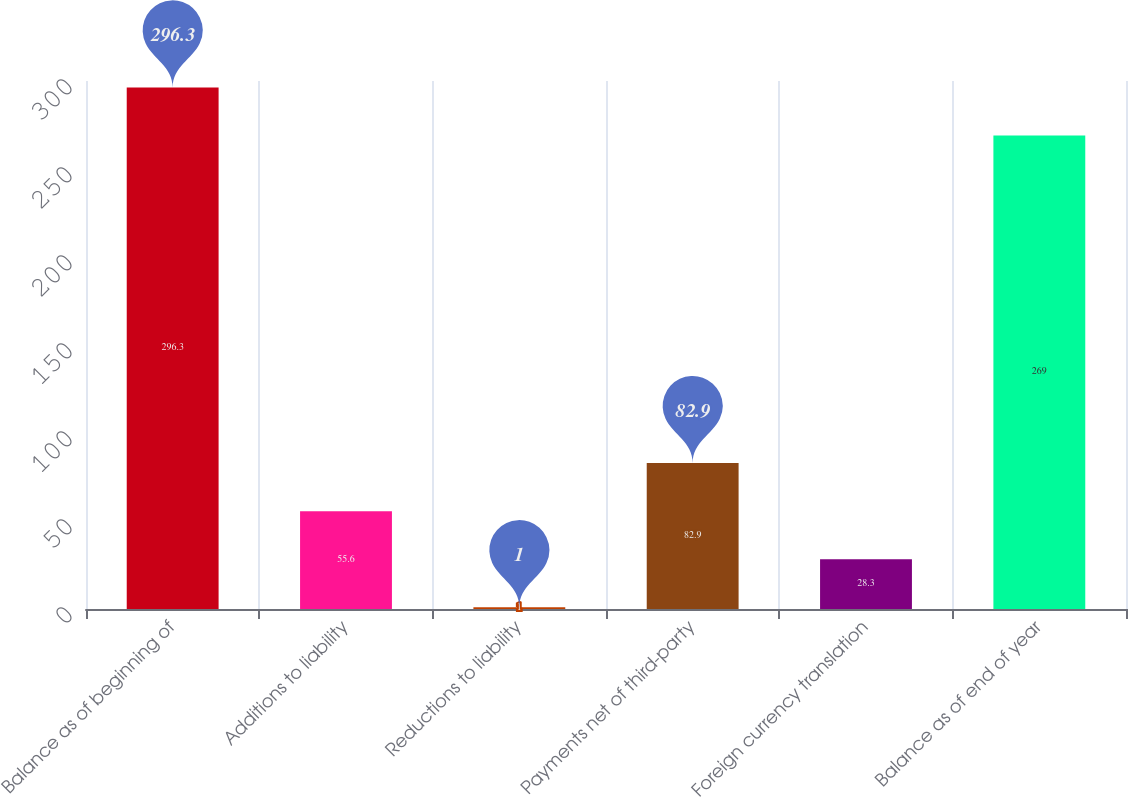Convert chart to OTSL. <chart><loc_0><loc_0><loc_500><loc_500><bar_chart><fcel>Balance as of beginning of<fcel>Additions to liability<fcel>Reductions to liability<fcel>Payments net of third-party<fcel>Foreign currency translation<fcel>Balance as of end of year<nl><fcel>296.3<fcel>55.6<fcel>1<fcel>82.9<fcel>28.3<fcel>269<nl></chart> 